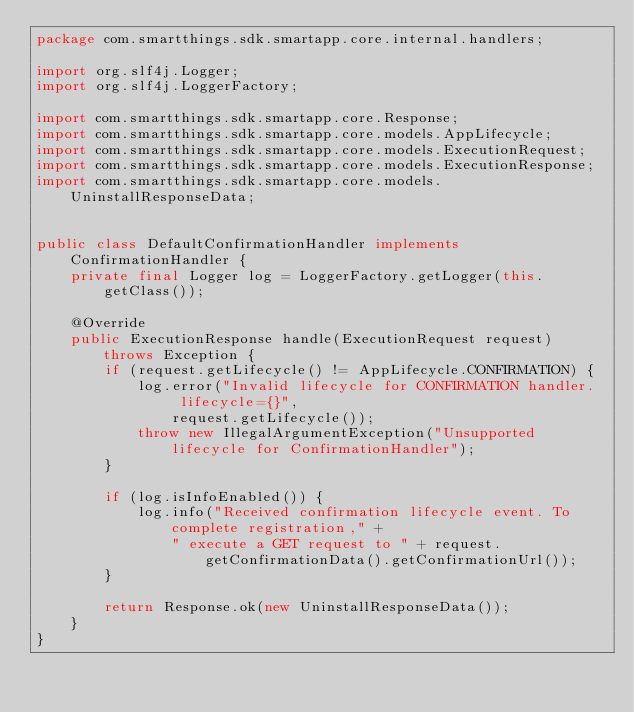<code> <loc_0><loc_0><loc_500><loc_500><_Java_>package com.smartthings.sdk.smartapp.core.internal.handlers;

import org.slf4j.Logger;
import org.slf4j.LoggerFactory;

import com.smartthings.sdk.smartapp.core.Response;
import com.smartthings.sdk.smartapp.core.models.AppLifecycle;
import com.smartthings.sdk.smartapp.core.models.ExecutionRequest;
import com.smartthings.sdk.smartapp.core.models.ExecutionResponse;
import com.smartthings.sdk.smartapp.core.models.UninstallResponseData;


public class DefaultConfirmationHandler implements ConfirmationHandler {
    private final Logger log = LoggerFactory.getLogger(this.getClass());

    @Override
    public ExecutionResponse handle(ExecutionRequest request) throws Exception {
        if (request.getLifecycle() != AppLifecycle.CONFIRMATION) {
            log.error("Invalid lifecycle for CONFIRMATION handler.  lifecycle={}",
                request.getLifecycle());
            throw new IllegalArgumentException("Unsupported lifecycle for ConfirmationHandler");
        }

        if (log.isInfoEnabled()) {
            log.info("Received confirmation lifecycle event. To complete registration," +
                " execute a GET request to " + request.getConfirmationData().getConfirmationUrl());
        }

        return Response.ok(new UninstallResponseData());
    }
}
</code> 